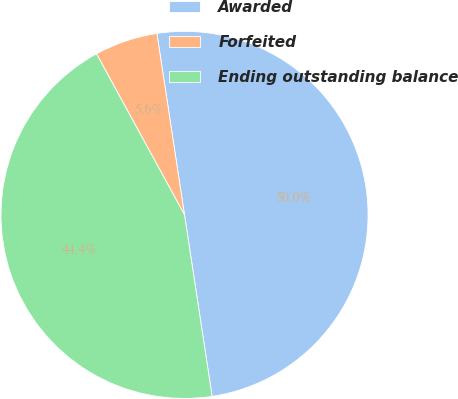Convert chart to OTSL. <chart><loc_0><loc_0><loc_500><loc_500><pie_chart><fcel>Awarded<fcel>Forfeited<fcel>Ending outstanding balance<nl><fcel>50.0%<fcel>5.56%<fcel>44.44%<nl></chart> 